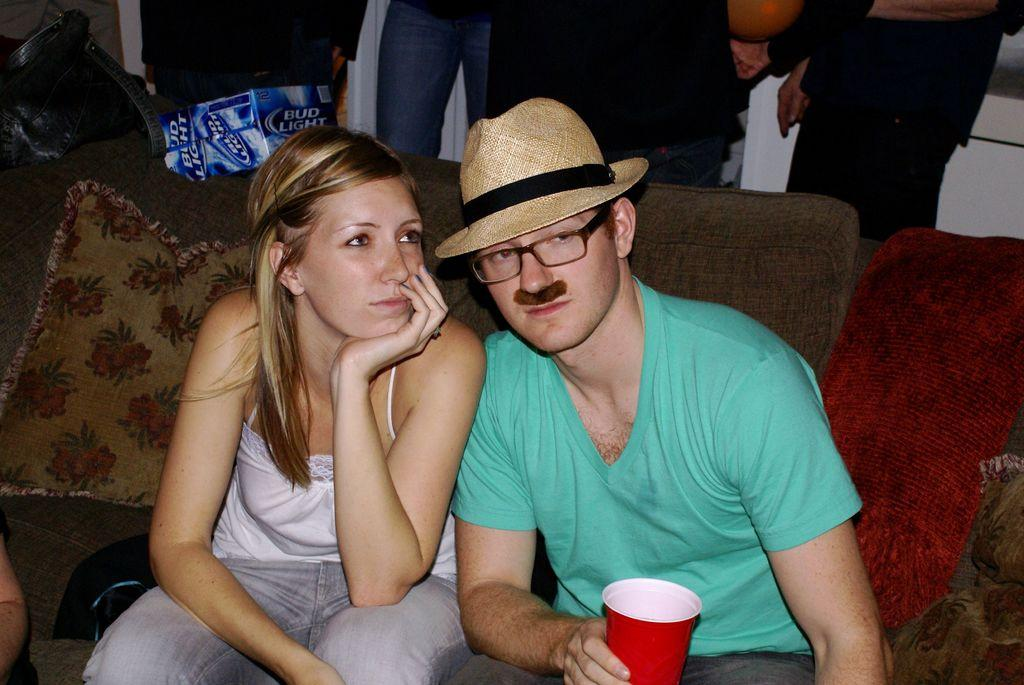Who are the people in the image? There is a boy and a girl in the image. What are they doing in the image? Both the boy and girl are sitting on a couch. What are they holding in their hands? The boy is holding a cup, and the girl is also holding a cup. What is the boy wearing on his head? The boy is wearing a cap. What color is the paint on the machine in the image? There is no paint or machine present in the image. How deep is the hole in the image? There is no hole present in the image. 